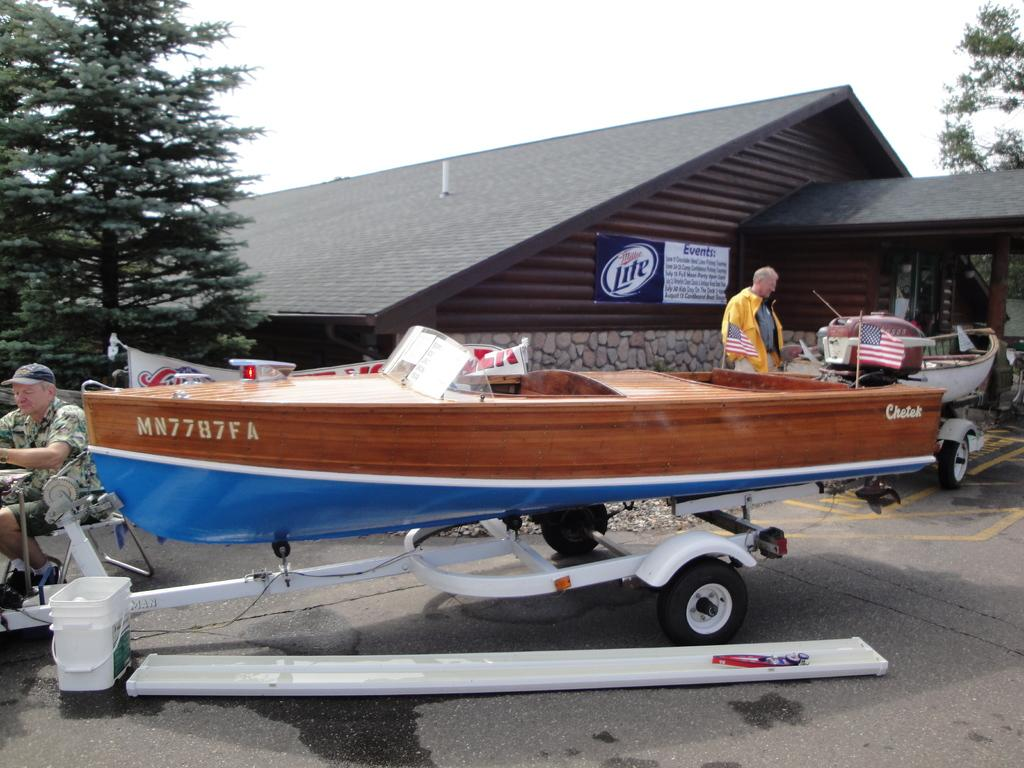<image>
Provide a brief description of the given image. a Cheteck motor boat outside a wood lodge 